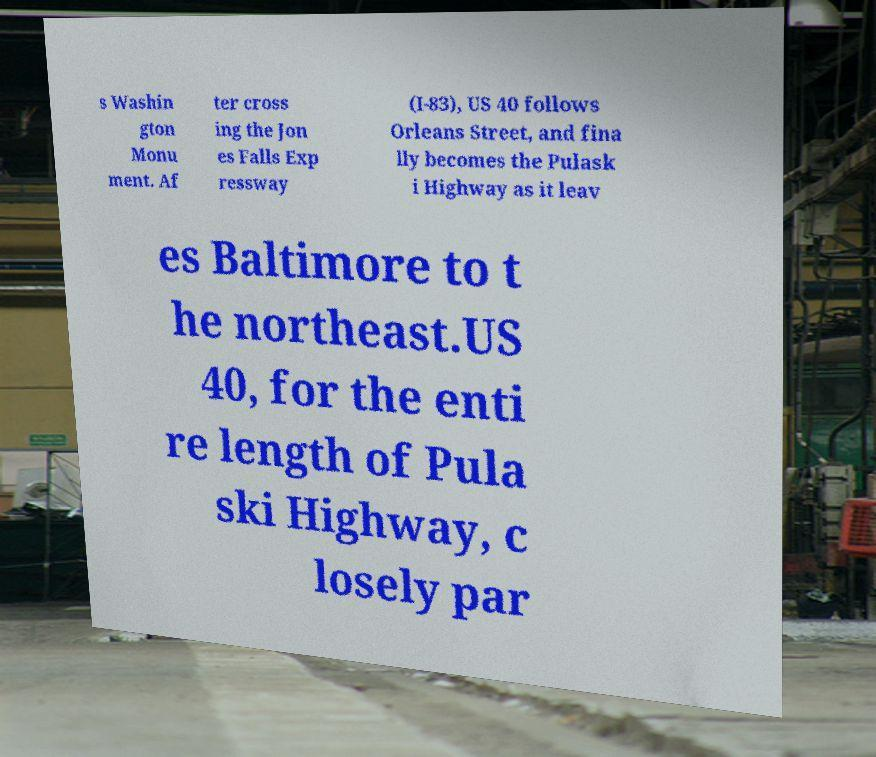Please identify and transcribe the text found in this image. s Washin gton Monu ment. Af ter cross ing the Jon es Falls Exp ressway (I-83), US 40 follows Orleans Street, and fina lly becomes the Pulask i Highway as it leav es Baltimore to t he northeast.US 40, for the enti re length of Pula ski Highway, c losely par 